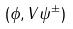<formula> <loc_0><loc_0><loc_500><loc_500>( \phi , V \psi ^ { \pm } )</formula> 